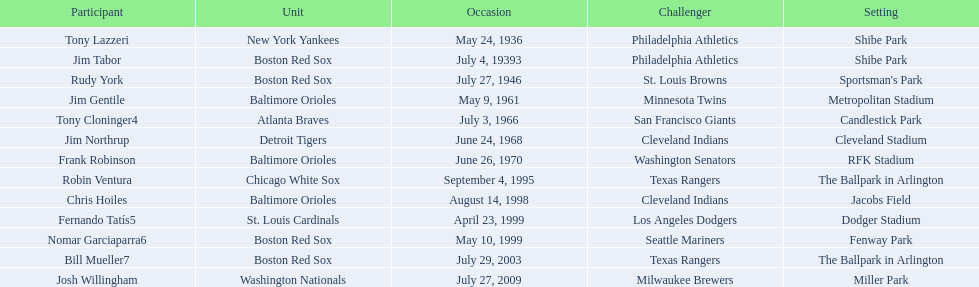What were the dates of each game? May 24, 1936, July 4, 19393, July 27, 1946, May 9, 1961, July 3, 1966, June 24, 1968, June 26, 1970, September 4, 1995, August 14, 1998, April 23, 1999, May 10, 1999, July 29, 2003, July 27, 2009. Who were all of the teams? New York Yankees, Boston Red Sox, Boston Red Sox, Baltimore Orioles, Atlanta Braves, Detroit Tigers, Baltimore Orioles, Chicago White Sox, Baltimore Orioles, St. Louis Cardinals, Boston Red Sox, Boston Red Sox, Washington Nationals. What about their opponents? Philadelphia Athletics, Philadelphia Athletics, St. Louis Browns, Minnesota Twins, San Francisco Giants, Cleveland Indians, Washington Senators, Texas Rangers, Cleveland Indians, Los Angeles Dodgers, Seattle Mariners, Texas Rangers, Milwaukee Brewers. And on which date did the detroit tigers play against the cleveland indians? June 24, 1968. 